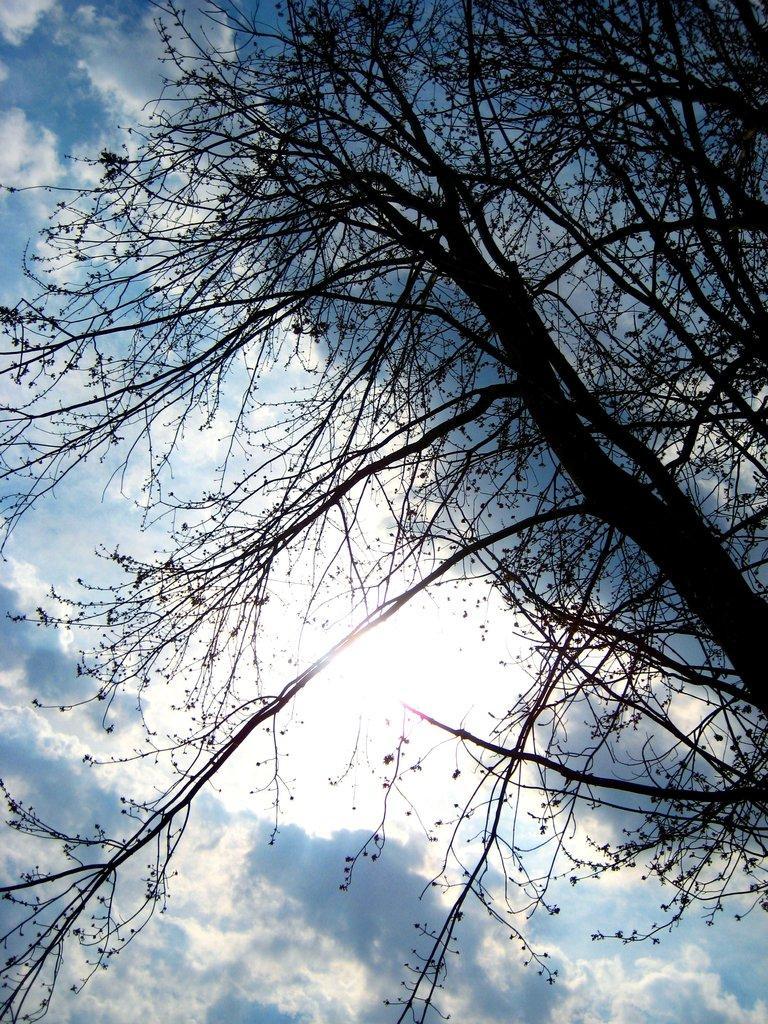Could you give a brief overview of what you see in this image? In the picture we can see a tree behind it we can see a sky with clouds. 